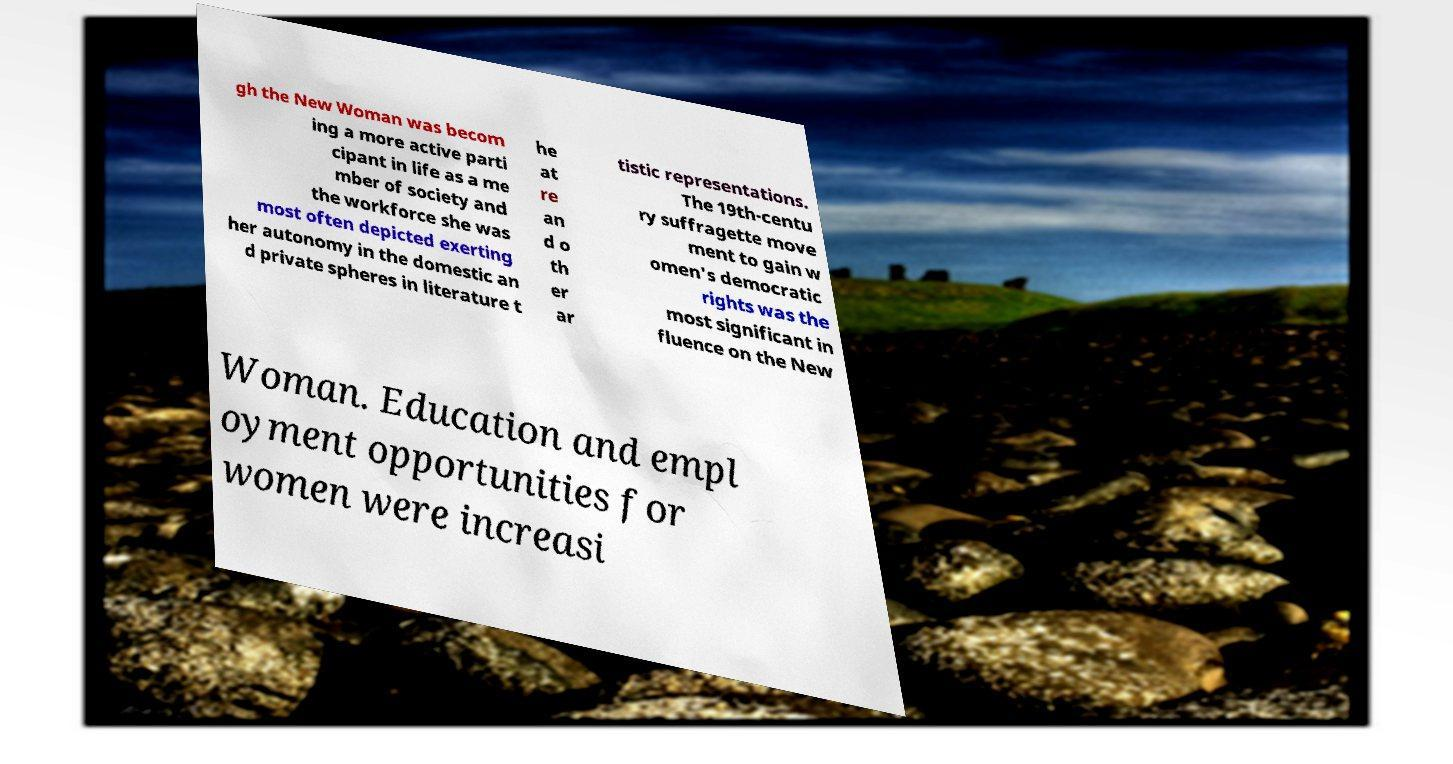Please identify and transcribe the text found in this image. gh the New Woman was becom ing a more active parti cipant in life as a me mber of society and the workforce she was most often depicted exerting her autonomy in the domestic an d private spheres in literature t he at re an d o th er ar tistic representations. The 19th-centu ry suffragette move ment to gain w omen's democratic rights was the most significant in fluence on the New Woman. Education and empl oyment opportunities for women were increasi 